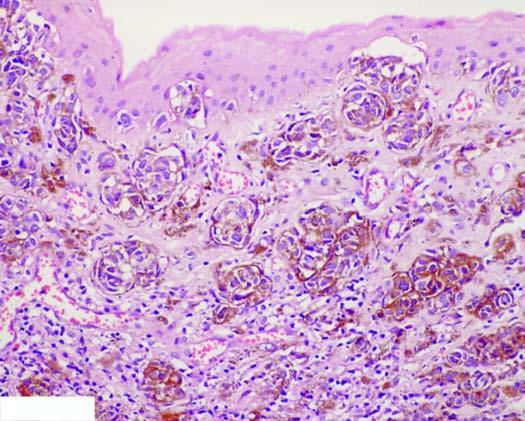what contain coarse, granular, brown-black melanin pigment?
Answer the question using a single word or phrase. These cells 